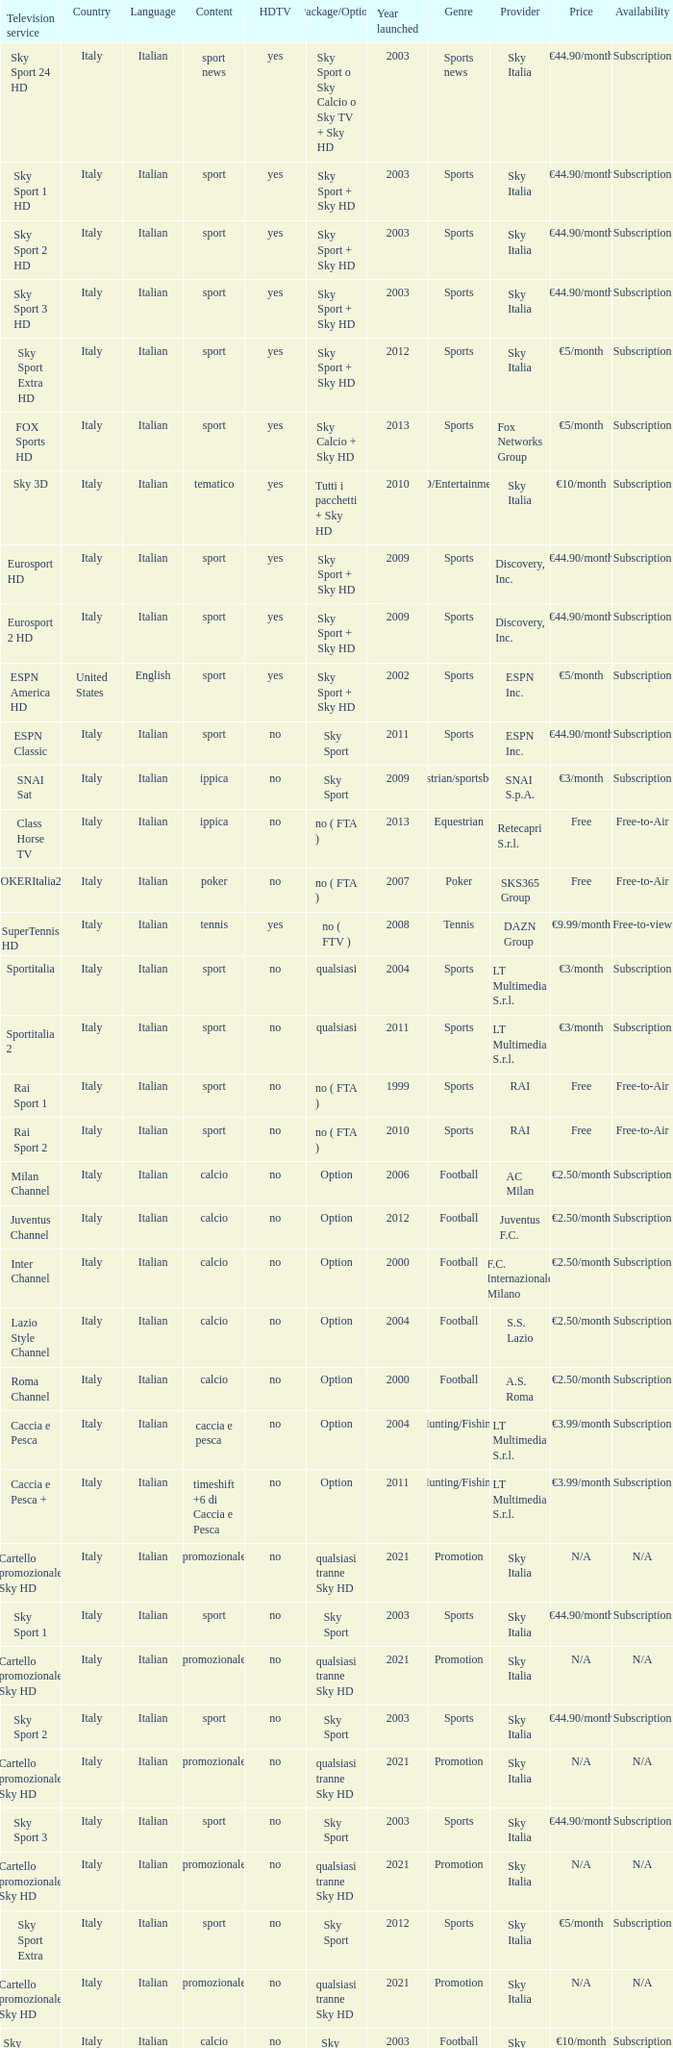What is Package/Option, when Content is Tennis? No ( ftv ). 